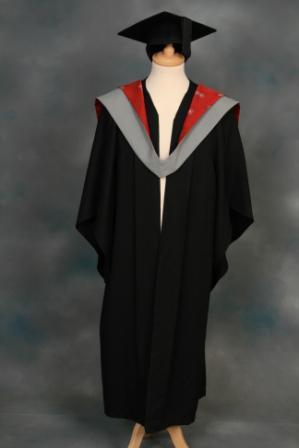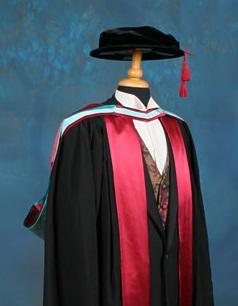The first image is the image on the left, the second image is the image on the right. Considering the images on both sides, is "A person is not shown in any of the images." valid? Answer yes or no. Yes. 